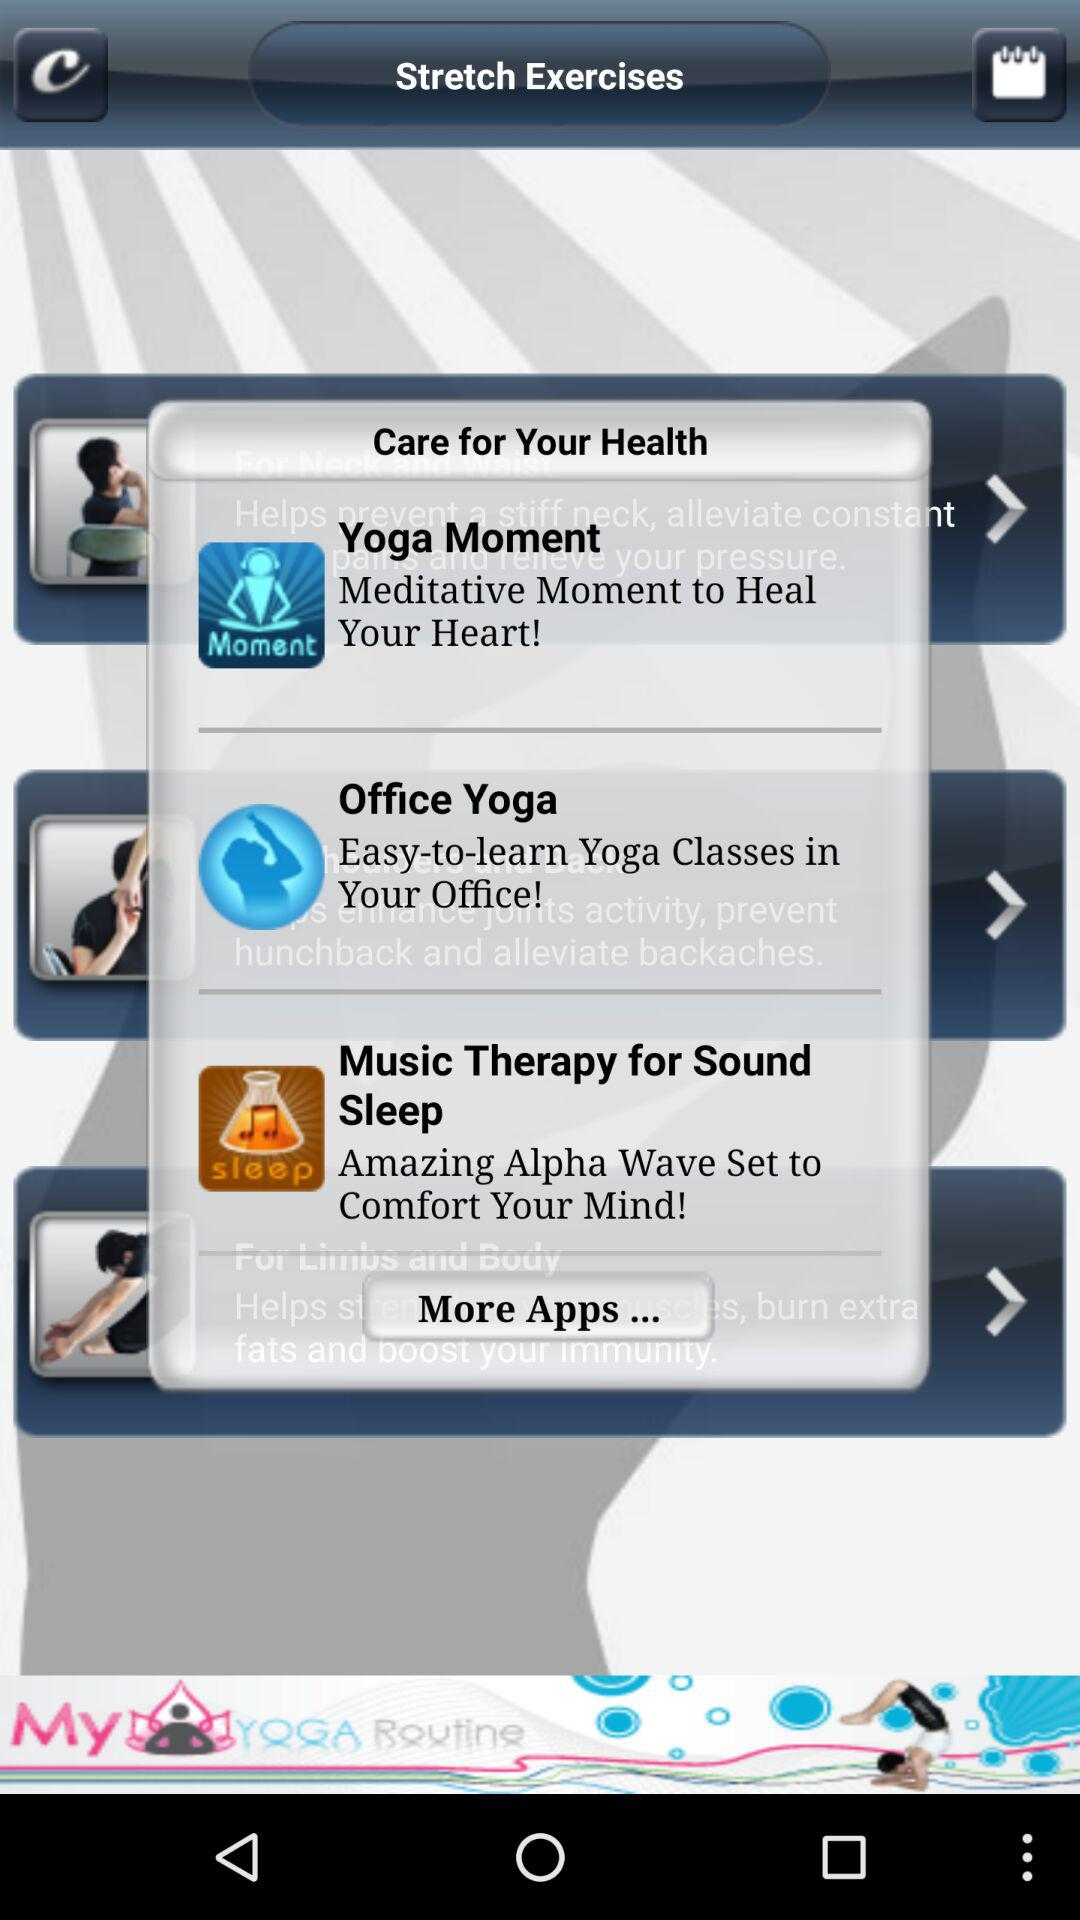Which stretching exercise heals your heart? The stretching exercise that heals your heart is "Yoga Moment". 